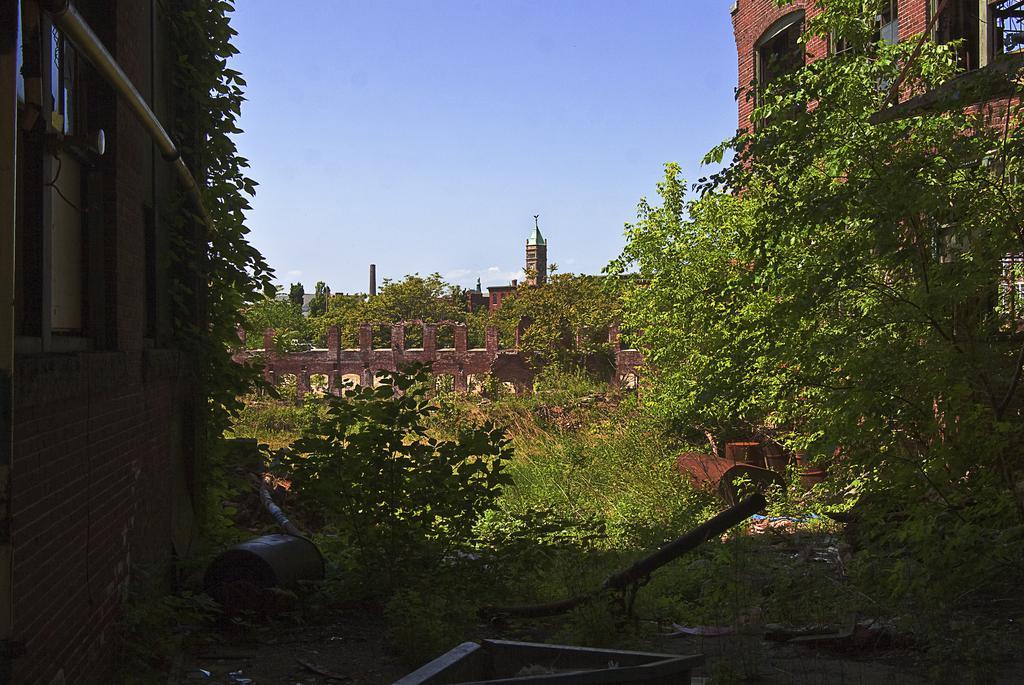How would you summarize this image in a sentence or two? In this image I can see a building, a pipe, a tree, the window and few other objects on the ground. In the background I can see few buildings, few trees and the sky. 